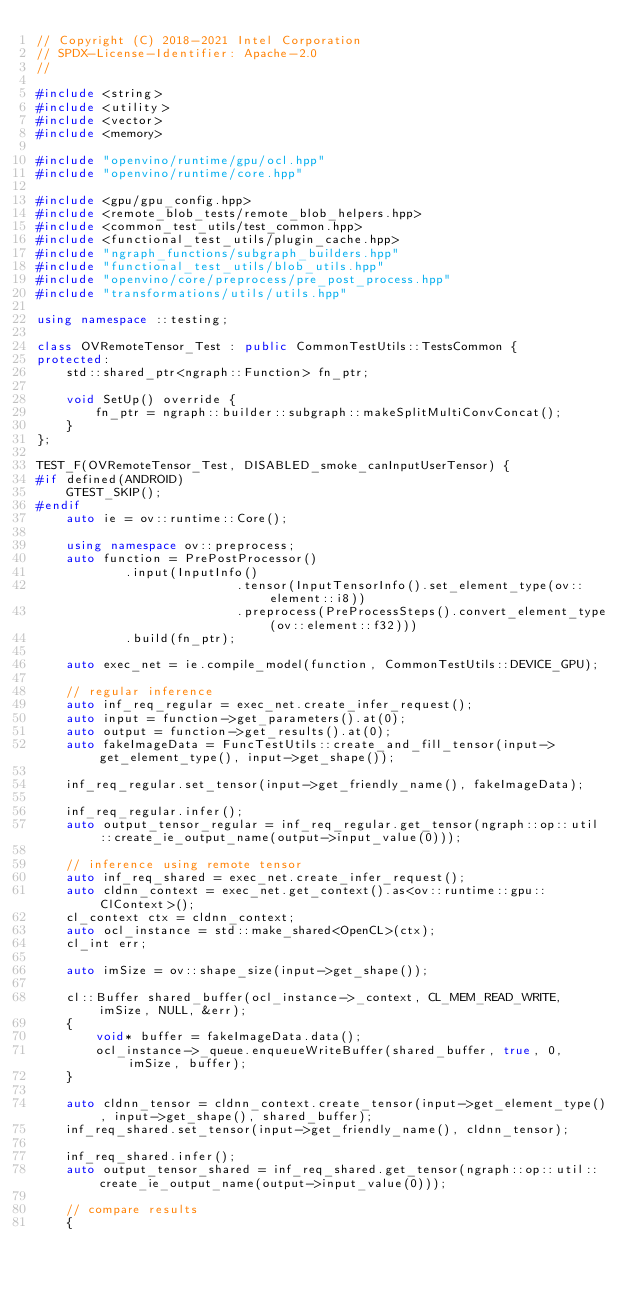Convert code to text. <code><loc_0><loc_0><loc_500><loc_500><_C++_>// Copyright (C) 2018-2021 Intel Corporation
// SPDX-License-Identifier: Apache-2.0
//

#include <string>
#include <utility>
#include <vector>
#include <memory>

#include "openvino/runtime/gpu/ocl.hpp"
#include "openvino/runtime/core.hpp"

#include <gpu/gpu_config.hpp>
#include <remote_blob_tests/remote_blob_helpers.hpp>
#include <common_test_utils/test_common.hpp>
#include <functional_test_utils/plugin_cache.hpp>
#include "ngraph_functions/subgraph_builders.hpp"
#include "functional_test_utils/blob_utils.hpp"
#include "openvino/core/preprocess/pre_post_process.hpp"
#include "transformations/utils/utils.hpp"

using namespace ::testing;

class OVRemoteTensor_Test : public CommonTestUtils::TestsCommon {
protected:
    std::shared_ptr<ngraph::Function> fn_ptr;

    void SetUp() override {
        fn_ptr = ngraph::builder::subgraph::makeSplitMultiConvConcat();
    }
};

TEST_F(OVRemoteTensor_Test, DISABLED_smoke_canInputUserTensor) {
#if defined(ANDROID)
    GTEST_SKIP();
#endif
    auto ie = ov::runtime::Core();

    using namespace ov::preprocess;
    auto function = PrePostProcessor()
            .input(InputInfo()
                           .tensor(InputTensorInfo().set_element_type(ov::element::i8))
                           .preprocess(PreProcessSteps().convert_element_type(ov::element::f32)))
            .build(fn_ptr);

    auto exec_net = ie.compile_model(function, CommonTestUtils::DEVICE_GPU);

    // regular inference
    auto inf_req_regular = exec_net.create_infer_request();
    auto input = function->get_parameters().at(0);
    auto output = function->get_results().at(0);
    auto fakeImageData = FuncTestUtils::create_and_fill_tensor(input->get_element_type(), input->get_shape());

    inf_req_regular.set_tensor(input->get_friendly_name(), fakeImageData);

    inf_req_regular.infer();
    auto output_tensor_regular = inf_req_regular.get_tensor(ngraph::op::util::create_ie_output_name(output->input_value(0)));

    // inference using remote tensor
    auto inf_req_shared = exec_net.create_infer_request();
    auto cldnn_context = exec_net.get_context().as<ov::runtime::gpu::ClContext>();
    cl_context ctx = cldnn_context;
    auto ocl_instance = std::make_shared<OpenCL>(ctx);
    cl_int err;

    auto imSize = ov::shape_size(input->get_shape());

    cl::Buffer shared_buffer(ocl_instance->_context, CL_MEM_READ_WRITE, imSize, NULL, &err);
    {
        void* buffer = fakeImageData.data();
        ocl_instance->_queue.enqueueWriteBuffer(shared_buffer, true, 0, imSize, buffer);
    }

    auto cldnn_tensor = cldnn_context.create_tensor(input->get_element_type(), input->get_shape(), shared_buffer);
    inf_req_shared.set_tensor(input->get_friendly_name(), cldnn_tensor);

    inf_req_shared.infer();
    auto output_tensor_shared = inf_req_shared.get_tensor(ngraph::op::util::create_ie_output_name(output->input_value(0)));

    // compare results
    {</code> 